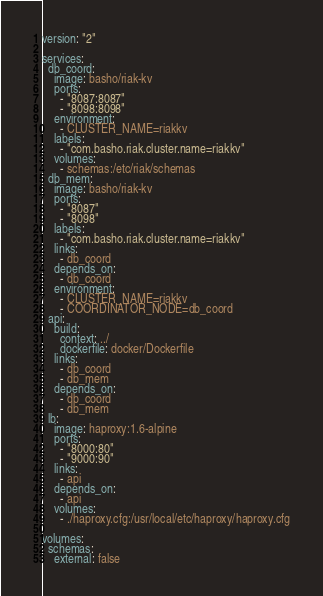<code> <loc_0><loc_0><loc_500><loc_500><_YAML_>version: "2"

services:
  db_coord:
    image: basho/riak-kv
    ports:
      - "8087:8087"
      - "8098:8098"
    environment:
      - CLUSTER_NAME=riakkv
    labels:
      - "com.basho.riak.cluster.name=riakkv"
    volumes:
      - schemas:/etc/riak/schemas
  db_mem:
    image: basho/riak-kv
    ports:
      - "8087"
      - "8098"
    labels:
      - "com.basho.riak.cluster.name=riakkv"
    links:
      - db_coord
    depends_on:
      - db_coord
    environment:
      - CLUSTER_NAME=riakkv
      - COORDINATOR_NODE=db_coord
  api:
    build:
      context: ../
      dockerfile: docker/Dockerfile
    links:
      - db_coord
      - db_mem
    depends_on:
      - db_coord
      - db_mem
  lb:
    image: haproxy:1.6-alpine
    ports:
      - "8000:80"
      - "9000:90"
    links:
      - api
    depends_on:
      - api
    volumes:
      - ./haproxy.cfg:/usr/local/etc/haproxy/haproxy.cfg

volumes:
  schemas:
    external: false
</code> 